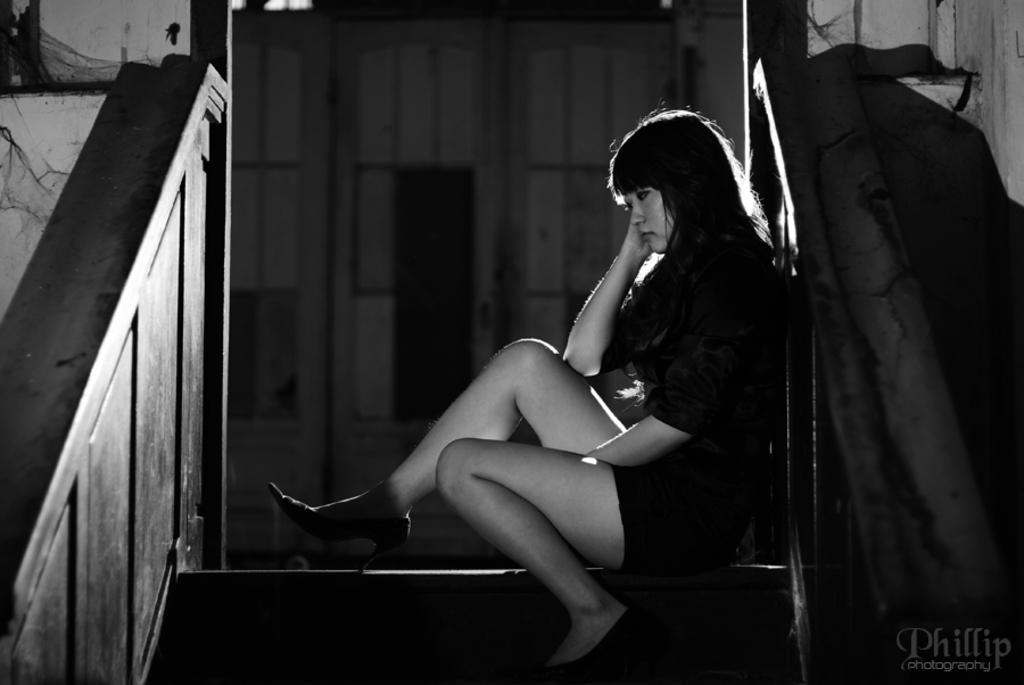What is the main subject in the foreground of the image? There is a woman sitting on a staircase in the foreground. What can be seen in the background of the image? There is a house and a door in the background. Can you describe the lighting conditions in the image? The image may have been taken during the night, as it appears to be dark. How many tomatoes are being carried by the porter in the image? There is no porter or tomatoes present in the image. 